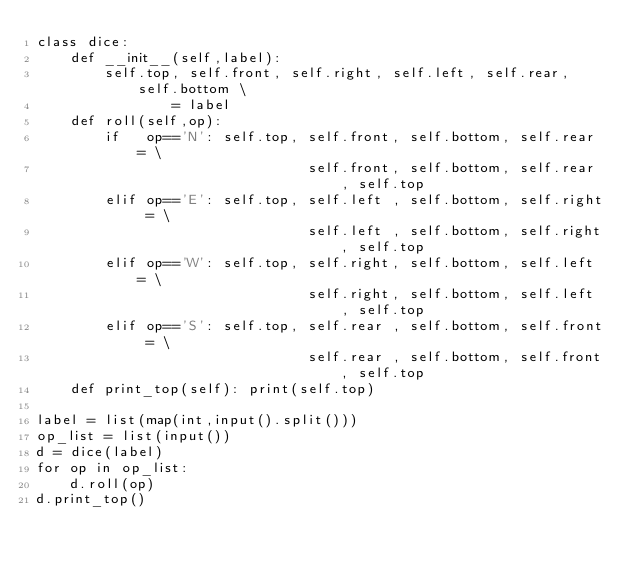Convert code to text. <code><loc_0><loc_0><loc_500><loc_500><_Python_>class dice:
    def __init__(self,label):
        self.top, self.front, self.right, self.left, self.rear, self.bottom \
                = label
    def roll(self,op):
        if   op=='N': self.top, self.front, self.bottom, self.rear = \
                                self.front, self.bottom, self.rear , self.top
        elif op=='E': self.top, self.left , self.bottom, self.right = \
                                self.left , self.bottom, self.right, self.top
        elif op=='W': self.top, self.right, self.bottom, self.left = \
                                self.right, self.bottom, self.left , self.top
        elif op=='S': self.top, self.rear , self.bottom, self.front = \
                                self.rear , self.bottom, self.front, self.top
    def print_top(self): print(self.top)
   
label = list(map(int,input().split()))
op_list = list(input())
d = dice(label)
for op in op_list:
    d.roll(op)
d.print_top()
</code> 